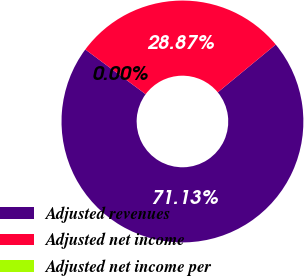<chart> <loc_0><loc_0><loc_500><loc_500><pie_chart><fcel>Adjusted revenues<fcel>Adjusted net income<fcel>Adjusted net income per<nl><fcel>71.13%<fcel>28.87%<fcel>0.0%<nl></chart> 